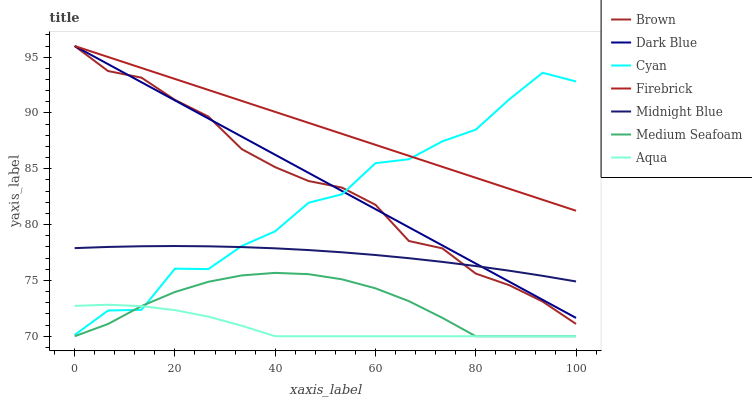Does Aqua have the minimum area under the curve?
Answer yes or no. Yes. Does Firebrick have the maximum area under the curve?
Answer yes or no. Yes. Does Midnight Blue have the minimum area under the curve?
Answer yes or no. No. Does Midnight Blue have the maximum area under the curve?
Answer yes or no. No. Is Dark Blue the smoothest?
Answer yes or no. Yes. Is Cyan the roughest?
Answer yes or no. Yes. Is Midnight Blue the smoothest?
Answer yes or no. No. Is Midnight Blue the roughest?
Answer yes or no. No. Does Aqua have the lowest value?
Answer yes or no. Yes. Does Midnight Blue have the lowest value?
Answer yes or no. No. Does Dark Blue have the highest value?
Answer yes or no. Yes. Does Midnight Blue have the highest value?
Answer yes or no. No. Is Medium Seafoam less than Firebrick?
Answer yes or no. Yes. Is Firebrick greater than Aqua?
Answer yes or no. Yes. Does Dark Blue intersect Brown?
Answer yes or no. Yes. Is Dark Blue less than Brown?
Answer yes or no. No. Is Dark Blue greater than Brown?
Answer yes or no. No. Does Medium Seafoam intersect Firebrick?
Answer yes or no. No. 